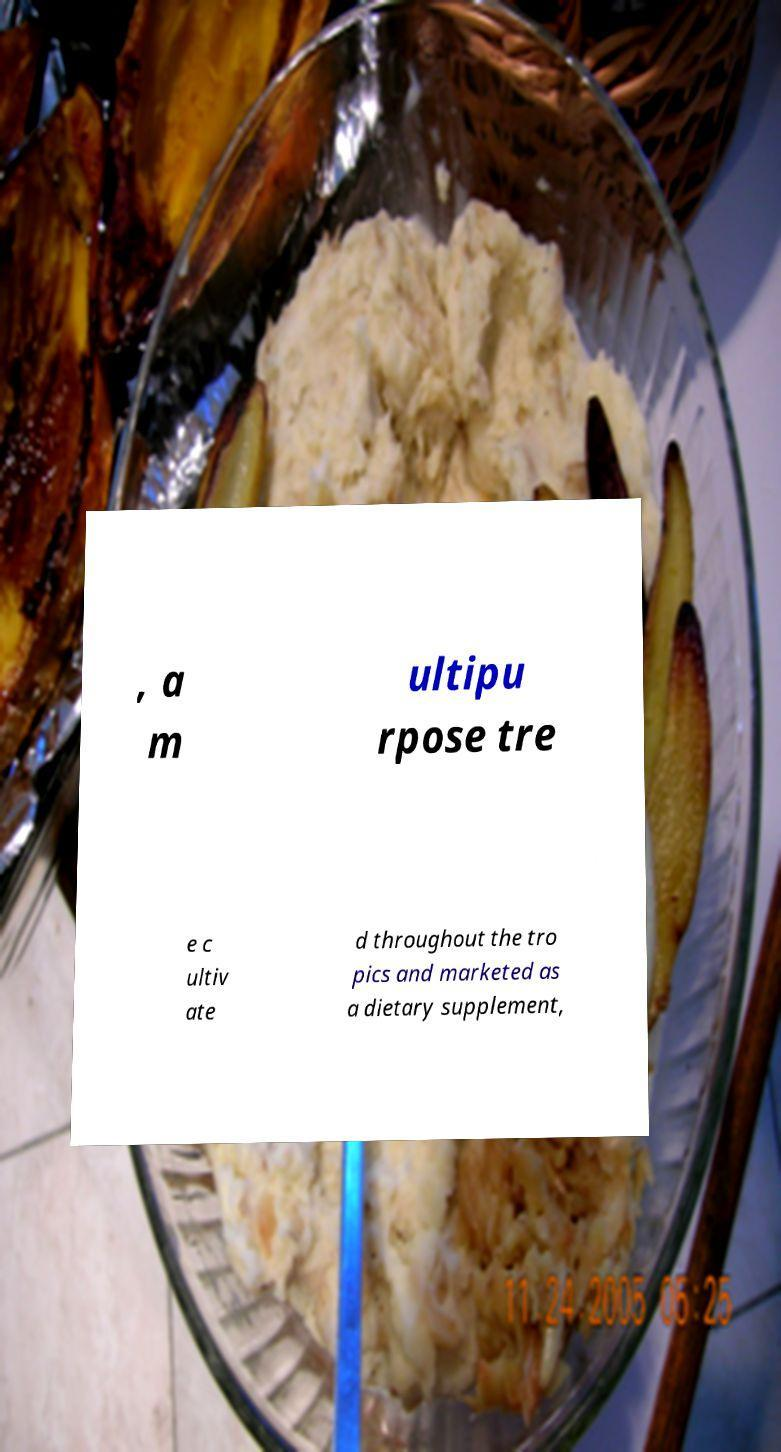For documentation purposes, I need the text within this image transcribed. Could you provide that? , a m ultipu rpose tre e c ultiv ate d throughout the tro pics and marketed as a dietary supplement, 